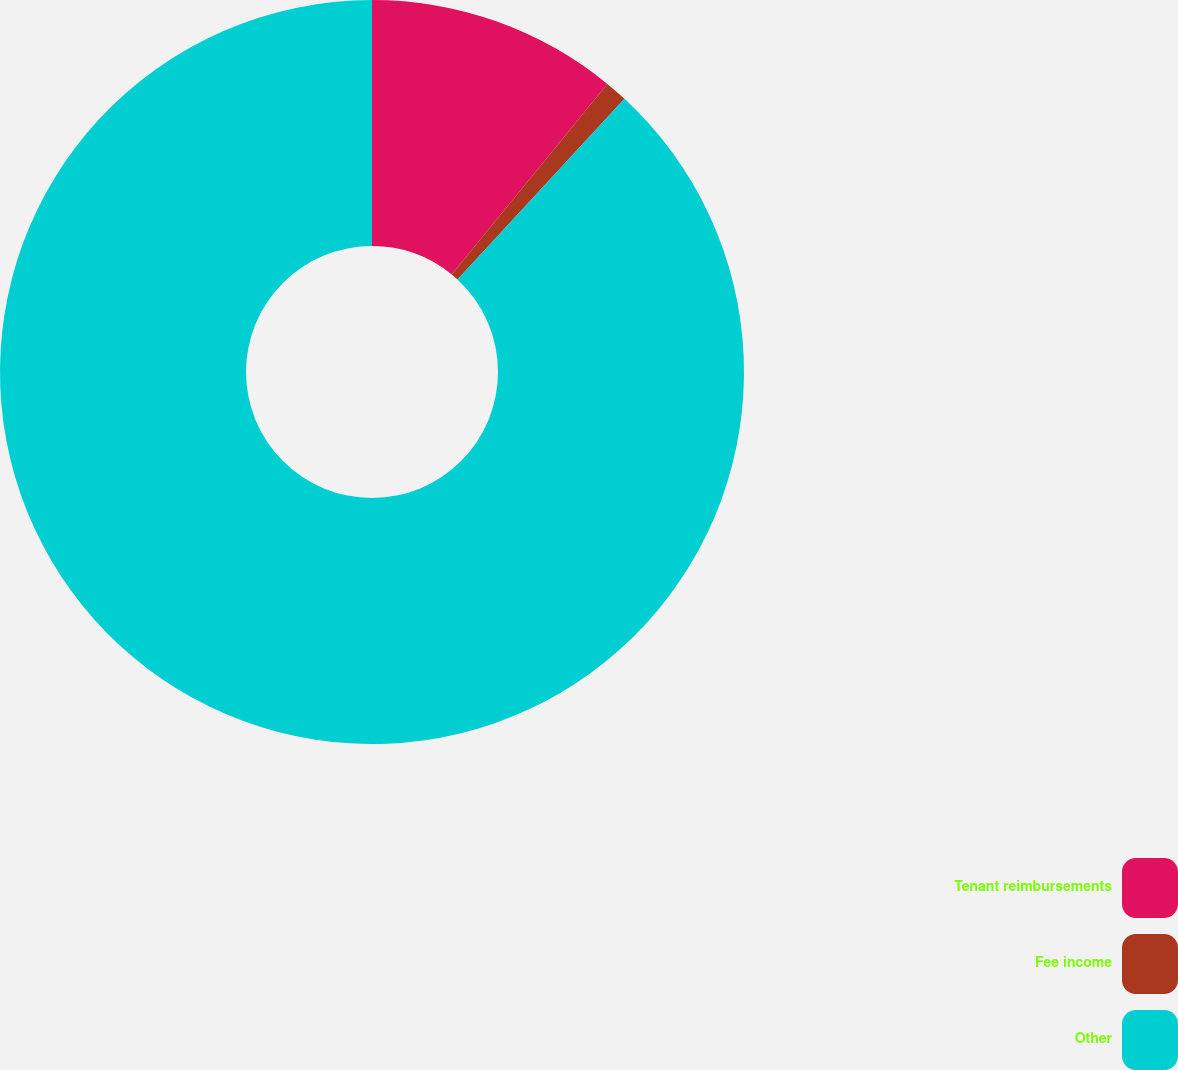<chart> <loc_0><loc_0><loc_500><loc_500><pie_chart><fcel>Tenant reimbursements<fcel>Fee income<fcel>Other<nl><fcel>10.9%<fcel>0.97%<fcel>88.13%<nl></chart> 